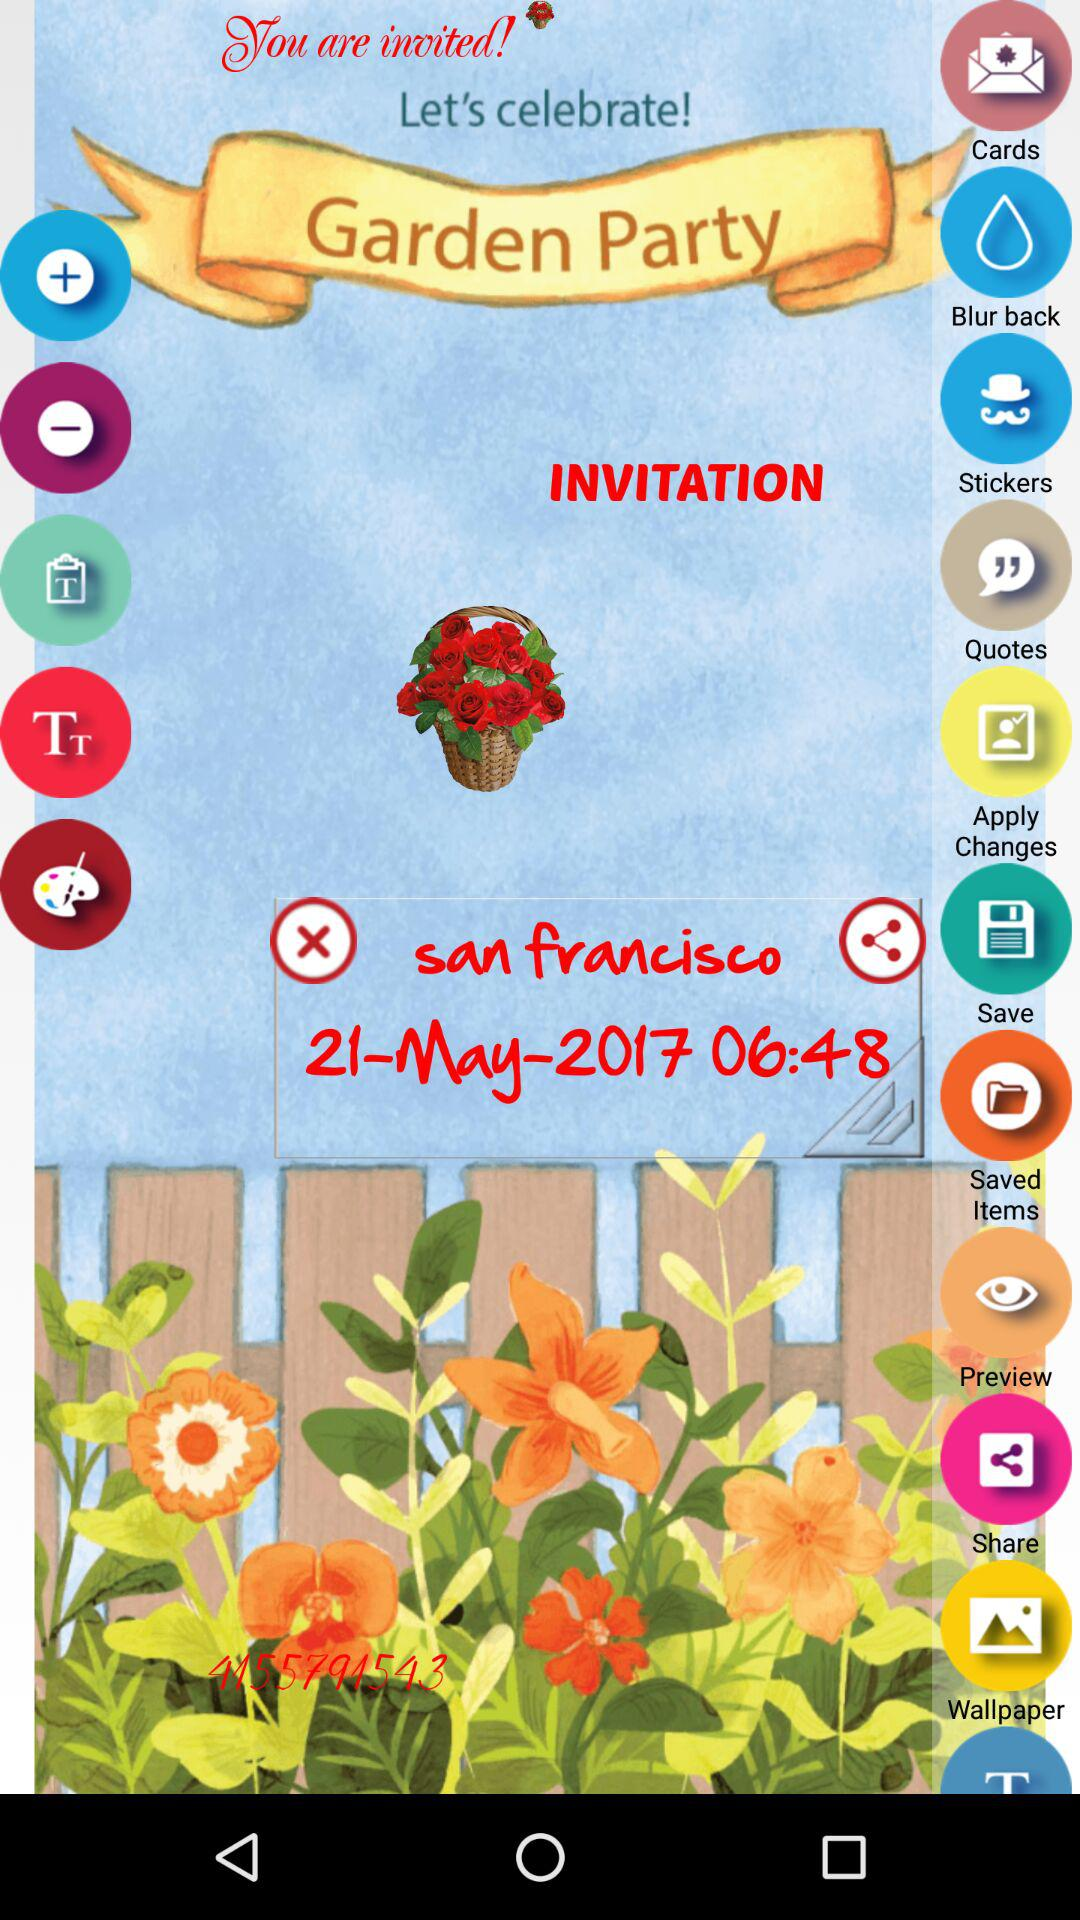What is the name of the party? The name of the party is "Garden Party". 